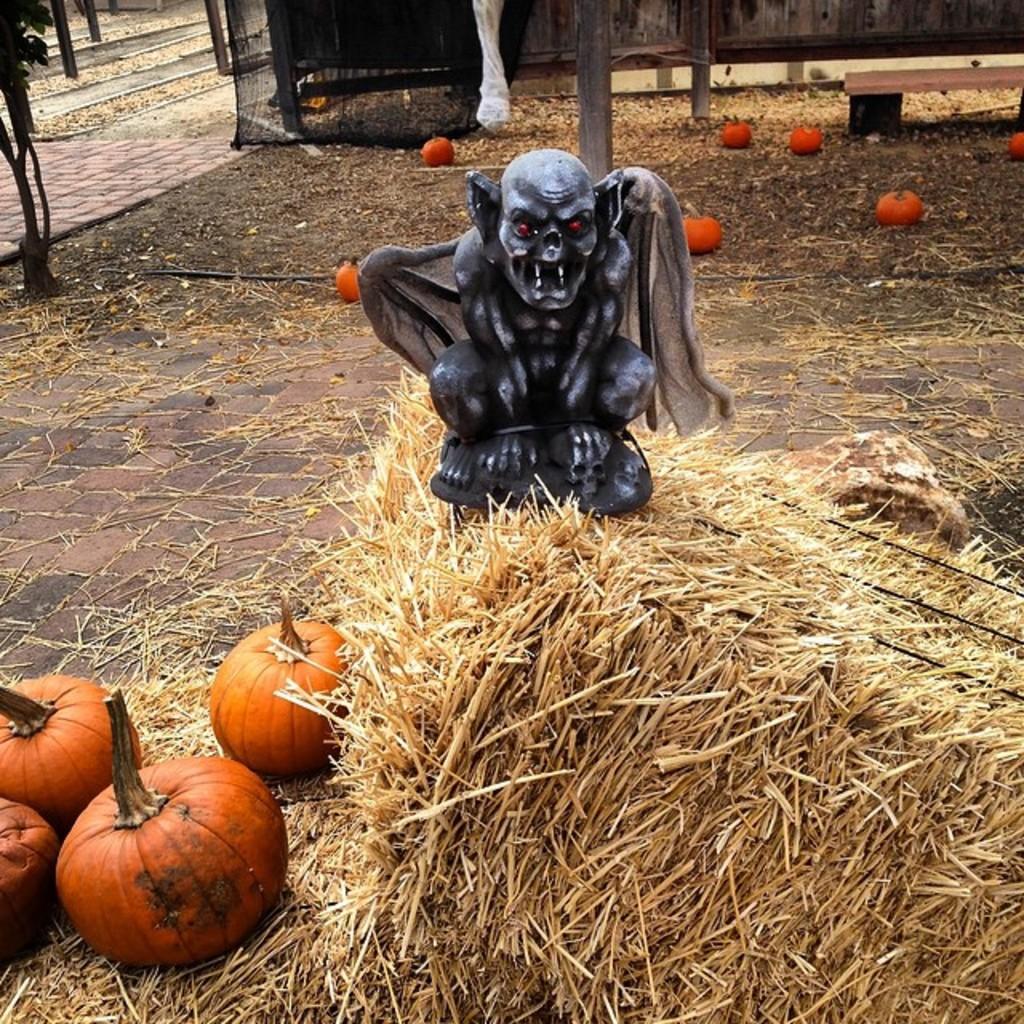Could you give a brief overview of what you see in this image? In this image there is a statue on dry grass, around the statue there are pumpkins. 